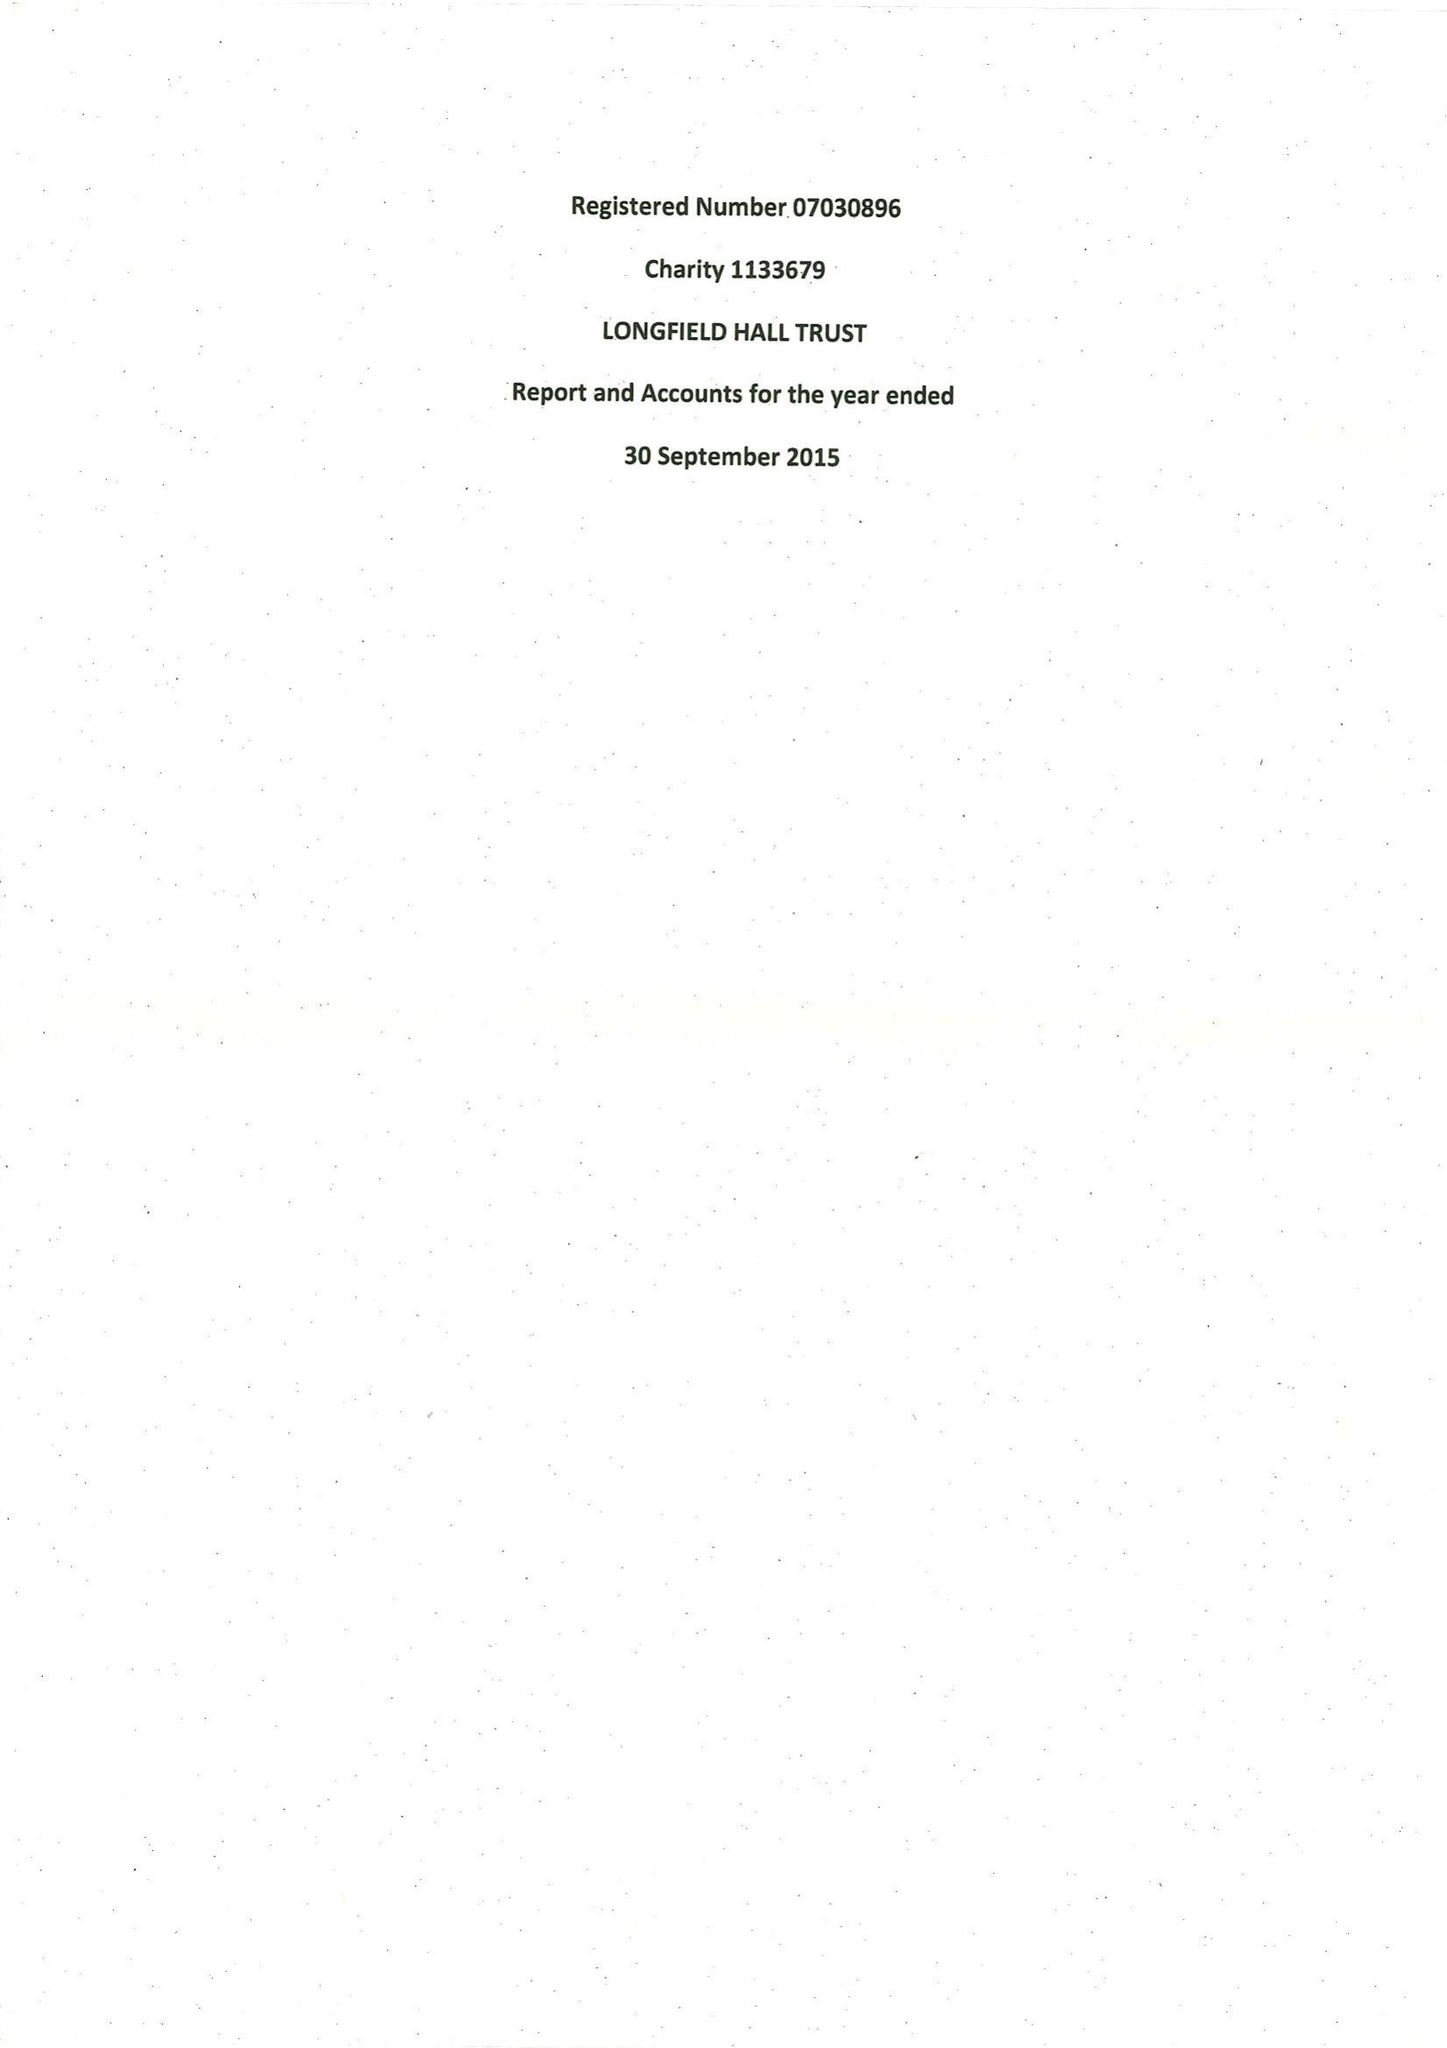What is the value for the spending_annually_in_british_pounds?
Answer the question using a single word or phrase. 138407.00 